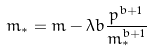Convert formula to latex. <formula><loc_0><loc_0><loc_500><loc_500>m _ { * } = m - \lambda b \frac { p ^ { b + 1 } } { m _ { * } ^ { b + 1 } }</formula> 